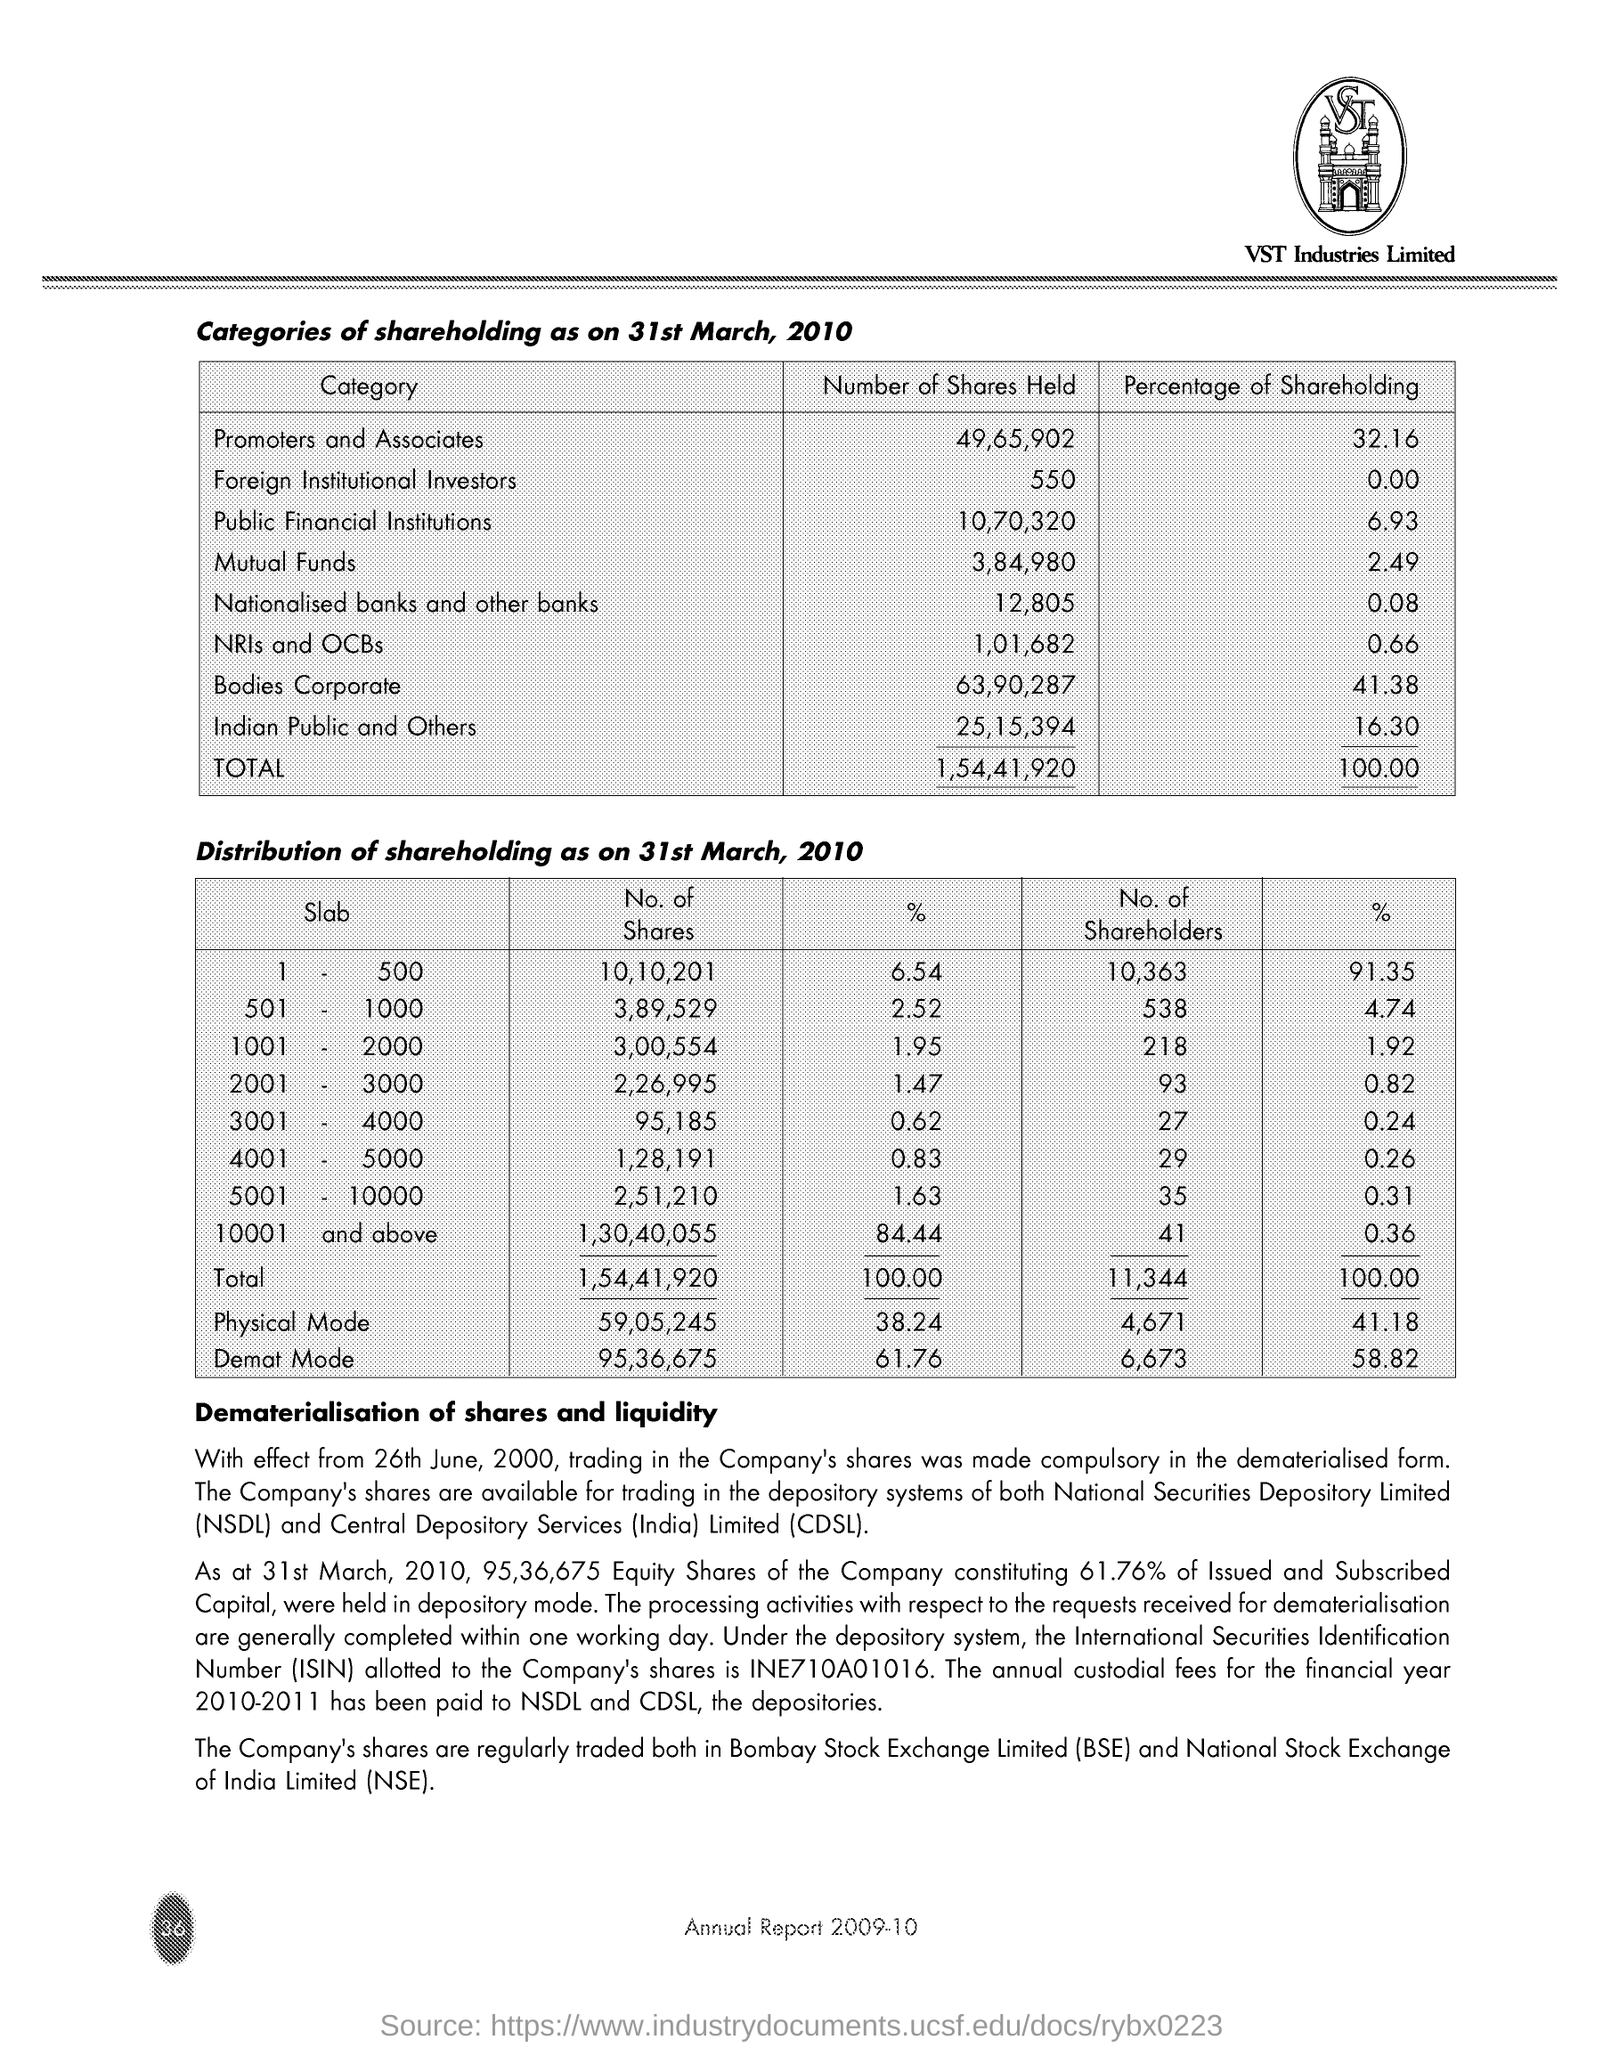Number of shares held by promoters and associates ?
Provide a succinct answer. 49,65,902. Percentage of share holding by promoters and associates ?
Provide a succinct answer. 32.16. Number of shares held by mutual funds ?
Offer a terse response. 3,84,980. Percentage of share holding by Mutual funds ?
Make the answer very short. 2.49. 